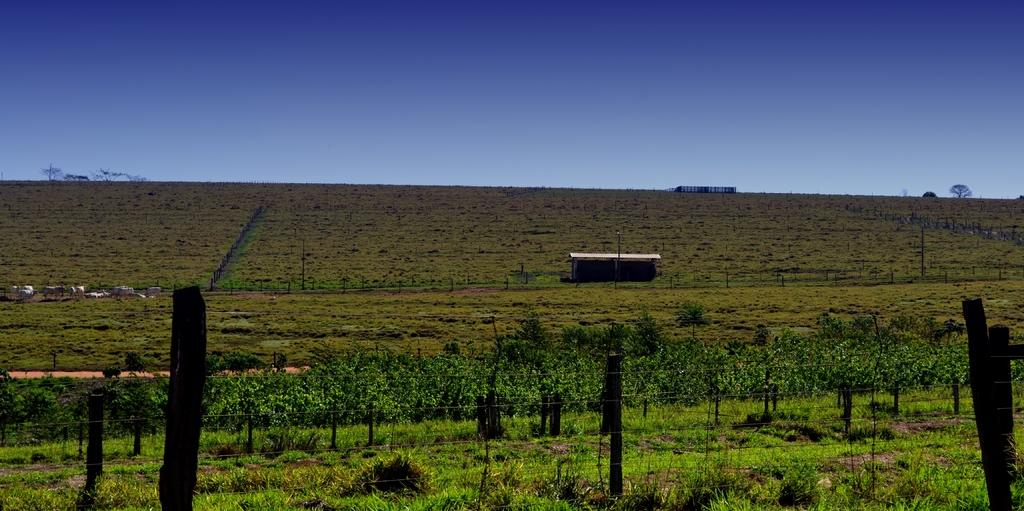What type of vegetation is present in the image? There are plants and grass in the image. What other living organisms can be seen in the image? There are animals in the image. What type of barrier is present in the image? There is a fence in the image. What structures can be seen in the image? There are poles in the image. What can be seen in the background of the image? There are trees and the sky visible in the background of the image. What type of queen is depicted on the poles in the image? There are no queens depicted on the poles in the image; they are simply poles. Can you tell me how many veins are visible in the image? There are no veins visible in the image; it features plants, grass, animals, a fence, poles, trees, and the sky. 